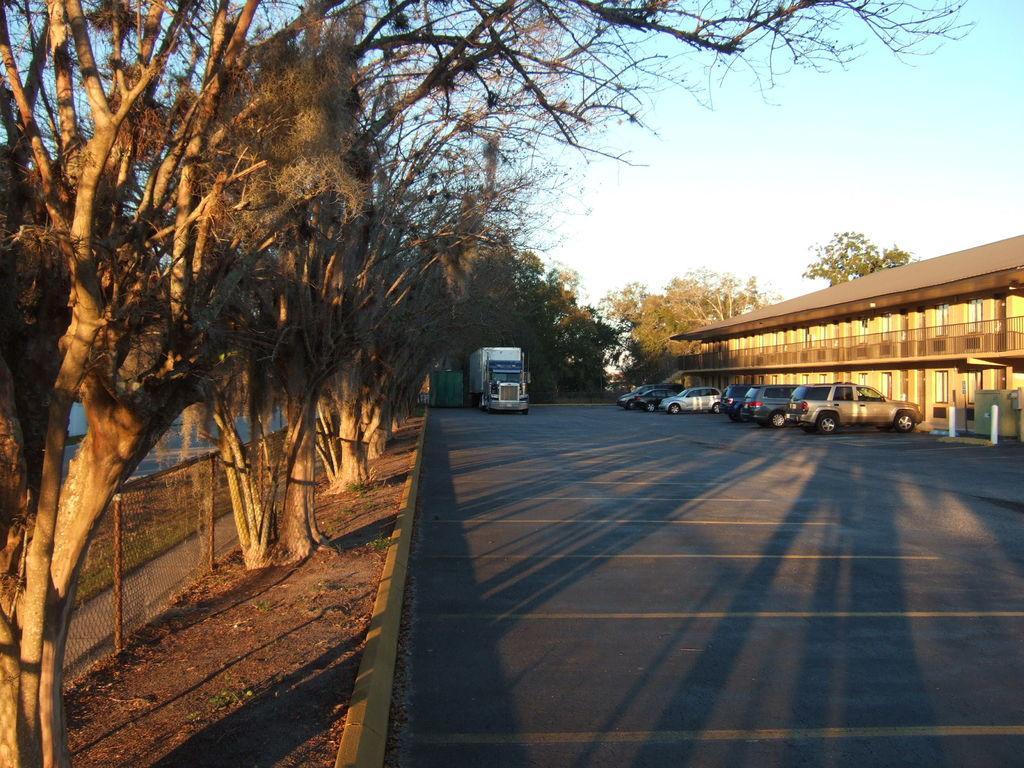Please provide a concise description of this image. In this image I can see few trees, buildings, vehicles, poles, railings and net fencing. The sky is in blue and white color. 